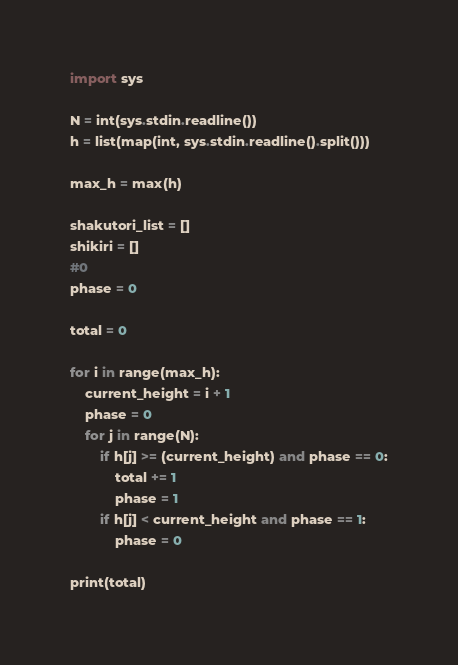<code> <loc_0><loc_0><loc_500><loc_500><_Python_>import sys

N = int(sys.stdin.readline())
h = list(map(int, sys.stdin.readline().split()))

max_h = max(h)

shakutori_list = []
shikiri = []
#0
phase = 0

total = 0

for i in range(max_h):
    current_height = i + 1
    phase = 0
    for j in range(N):
        if h[j] >= (current_height) and phase == 0:
            total += 1
            phase = 1
        if h[j] < current_height and phase == 1:
            phase = 0

print(total)</code> 